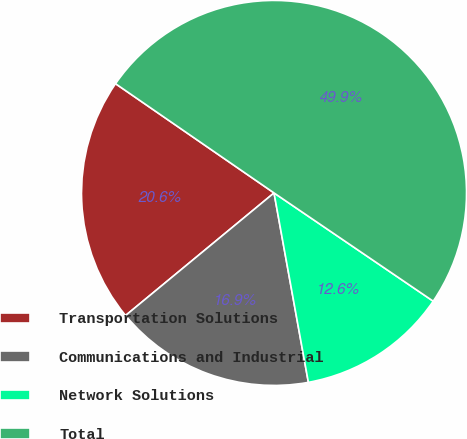Convert chart to OTSL. <chart><loc_0><loc_0><loc_500><loc_500><pie_chart><fcel>Transportation Solutions<fcel>Communications and Industrial<fcel>Network Solutions<fcel>Total<nl><fcel>20.59%<fcel>16.87%<fcel>12.64%<fcel>49.9%<nl></chart> 